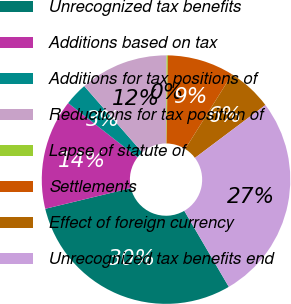Convert chart. <chart><loc_0><loc_0><loc_500><loc_500><pie_chart><fcel>Unrecognized tax benefits<fcel>Additions based on tax<fcel>Additions for tax positions of<fcel>Reductions for tax position of<fcel>Lapse of statute of<fcel>Settlements<fcel>Effect of foreign currency<fcel>Unrecognized tax benefits end<nl><fcel>29.66%<fcel>14.34%<fcel>3.0%<fcel>11.51%<fcel>0.17%<fcel>8.67%<fcel>5.84%<fcel>26.82%<nl></chart> 